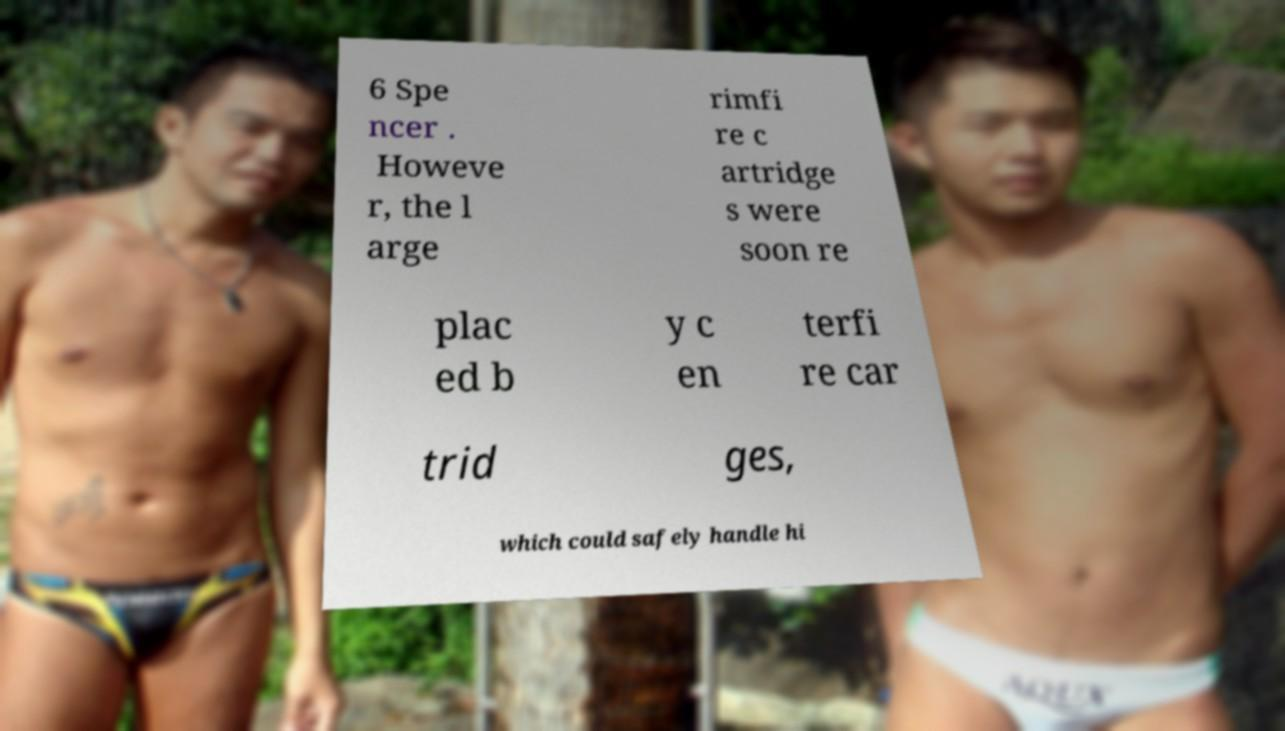Can you accurately transcribe the text from the provided image for me? 6 Spe ncer . Howeve r, the l arge rimfi re c artridge s were soon re plac ed b y c en terfi re car trid ges, which could safely handle hi 